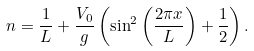<formula> <loc_0><loc_0><loc_500><loc_500>n = \frac { 1 } { L } + \frac { V _ { 0 } } { g } \left ( \sin ^ { 2 } \left ( \frac { 2 \pi x } { L } \right ) + \frac { 1 } { 2 } \right ) .</formula> 